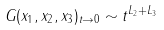<formula> <loc_0><loc_0><loc_500><loc_500>G ( x _ { 1 } , x _ { 2 } , x _ { 3 } ) _ { t \rightarrow 0 } \sim t ^ { L _ { 2 } + L _ { 3 } }</formula> 